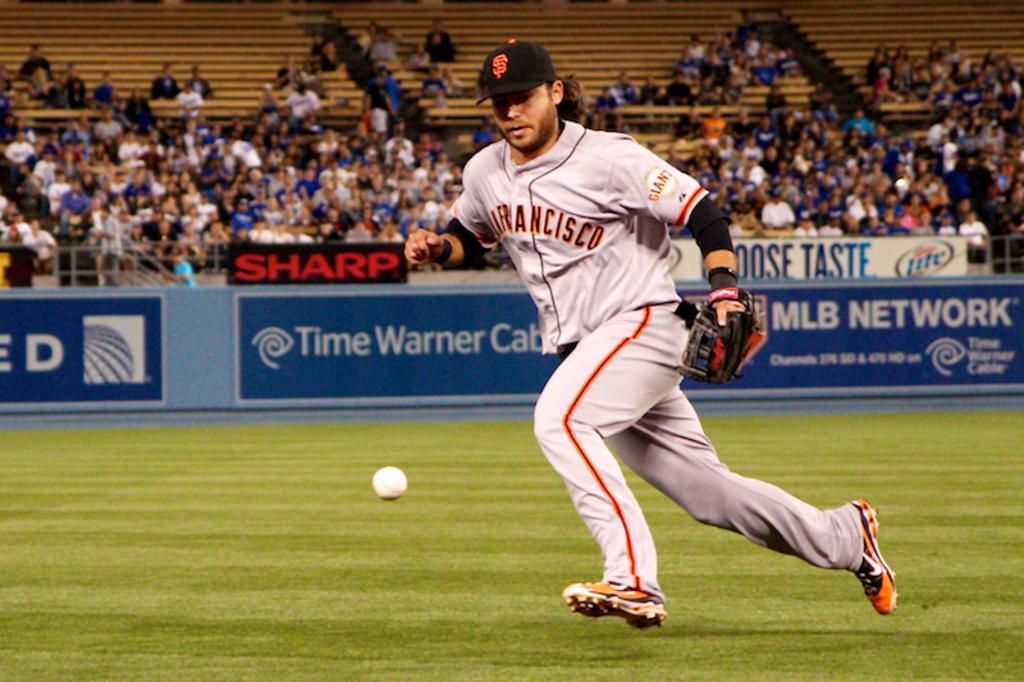What cable company is advertising on the sign?
Your answer should be very brief. Time warner cable. Which team is he representing?
Your answer should be very brief. San francisco. 